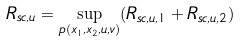Convert formula to latex. <formula><loc_0><loc_0><loc_500><loc_500>R _ { s c , u } = \sup _ { p ( x _ { 1 } , x _ { 2 } , u , v ) } ( R _ { s c , u , 1 } + R _ { s c , u , 2 } )</formula> 